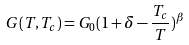<formula> <loc_0><loc_0><loc_500><loc_500>G ( T , T _ { c } ) = G _ { 0 } ( 1 + \delta - \frac { T _ { c } } { T } ) ^ { \beta }</formula> 